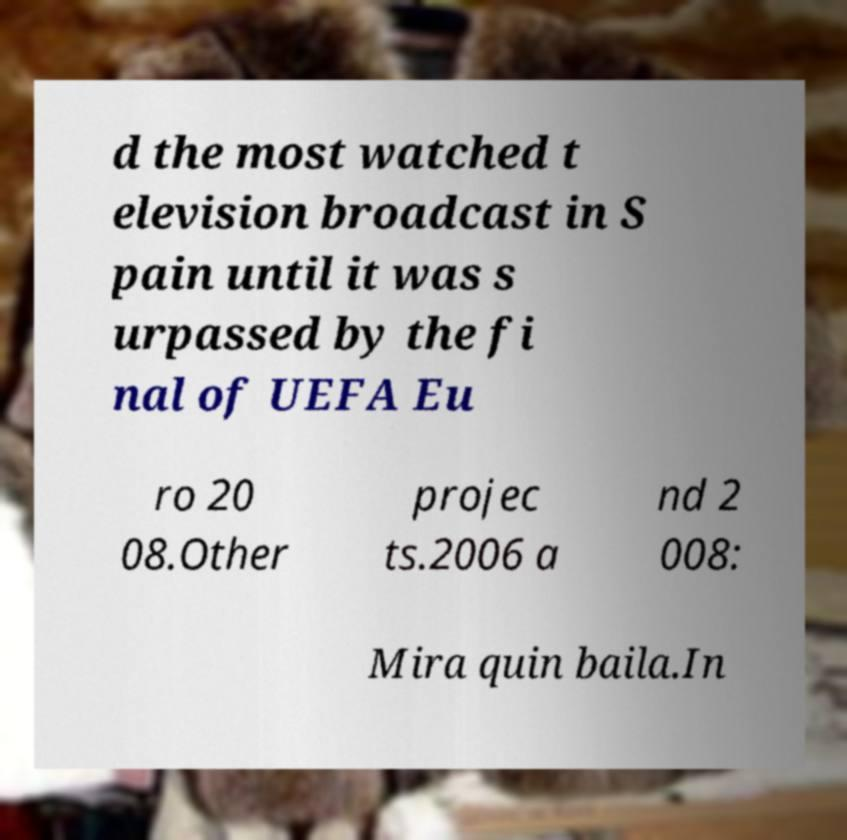Please read and relay the text visible in this image. What does it say? d the most watched t elevision broadcast in S pain until it was s urpassed by the fi nal of UEFA Eu ro 20 08.Other projec ts.2006 a nd 2 008: Mira quin baila.In 